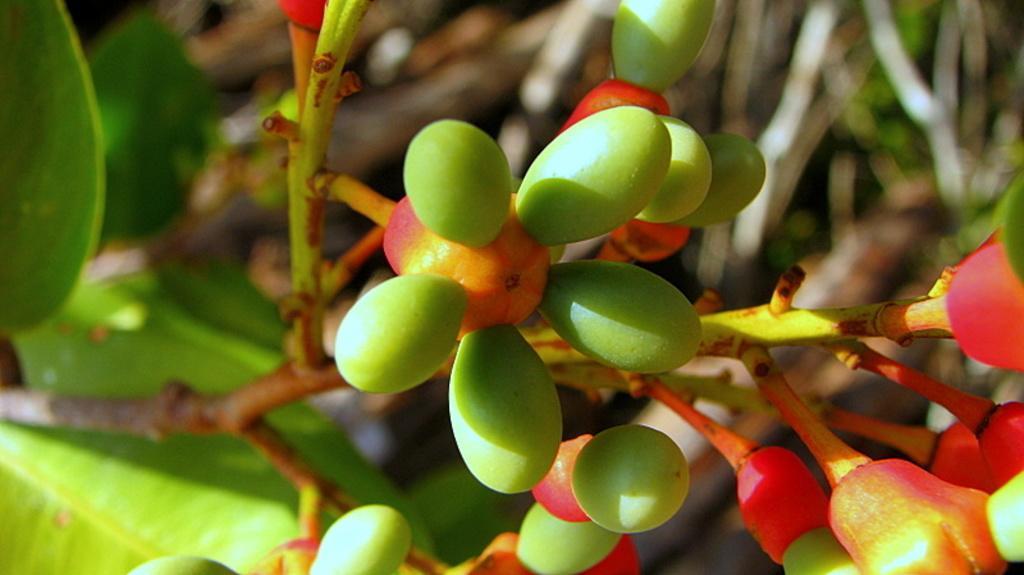Please provide a concise description of this image. In this picture I can see there are few fruits attached to the stem of a plant and there are few leaves and the backdrop is blurred. 